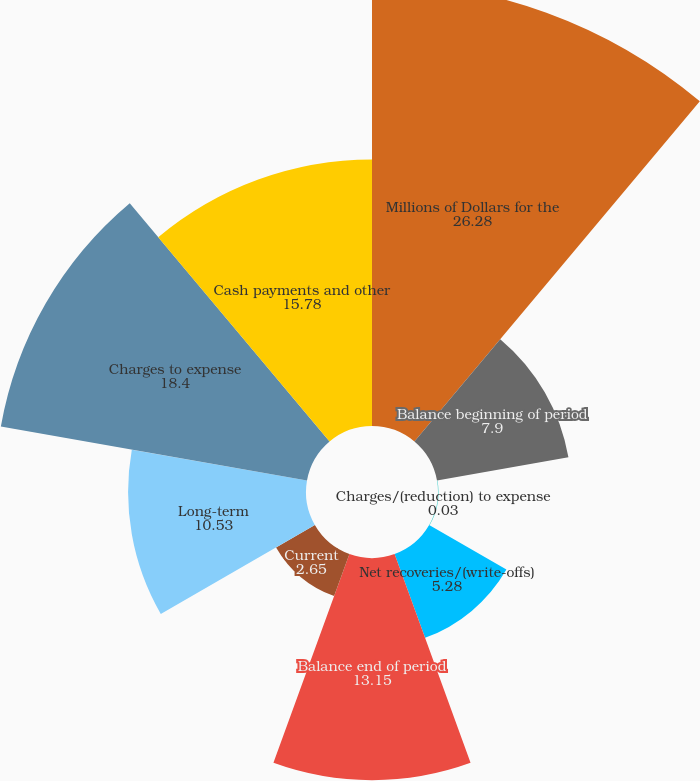Convert chart. <chart><loc_0><loc_0><loc_500><loc_500><pie_chart><fcel>Millions of Dollars for the<fcel>Balance beginning of period<fcel>Charges/(reduction) to expense<fcel>Net recoveries/(write-offs)<fcel>Balance end of period<fcel>Current<fcel>Long-term<fcel>Charges to expense<fcel>Cash payments and other<nl><fcel>26.28%<fcel>7.9%<fcel>0.03%<fcel>5.28%<fcel>13.15%<fcel>2.65%<fcel>10.53%<fcel>18.4%<fcel>15.78%<nl></chart> 